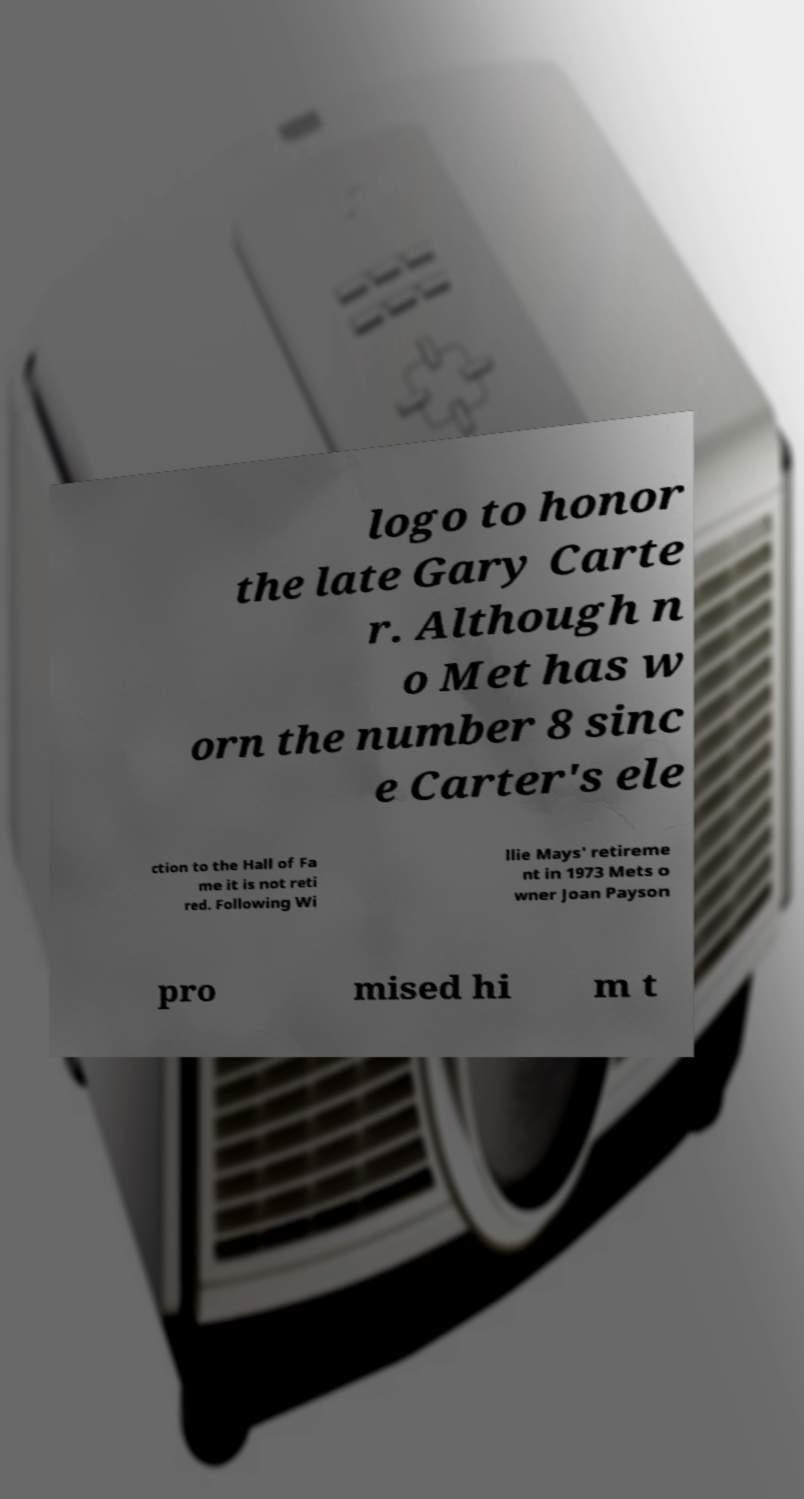Could you extract and type out the text from this image? logo to honor the late Gary Carte r. Although n o Met has w orn the number 8 sinc e Carter's ele ction to the Hall of Fa me it is not reti red. Following Wi llie Mays' retireme nt in 1973 Mets o wner Joan Payson pro mised hi m t 